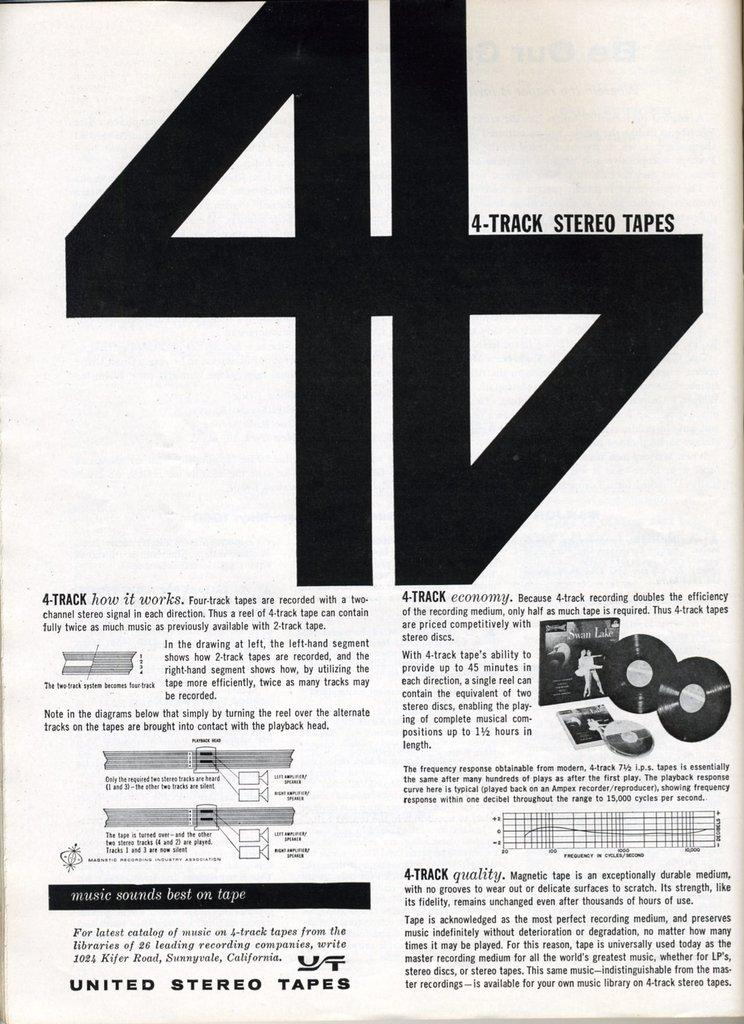<image>
Summarize the visual content of the image. An article put out by United Stereo Tapes that discuses 4-tracks. 